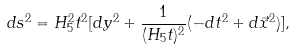Convert formula to latex. <formula><loc_0><loc_0><loc_500><loc_500>d s ^ { 2 } = H _ { 5 } ^ { 2 } t ^ { 2 } [ d y ^ { 2 } + \frac { 1 } { ( H _ { 5 } t ) ^ { 2 } } ( - d t ^ { 2 } + d \vec { x } ^ { 2 } ) ] ,</formula> 